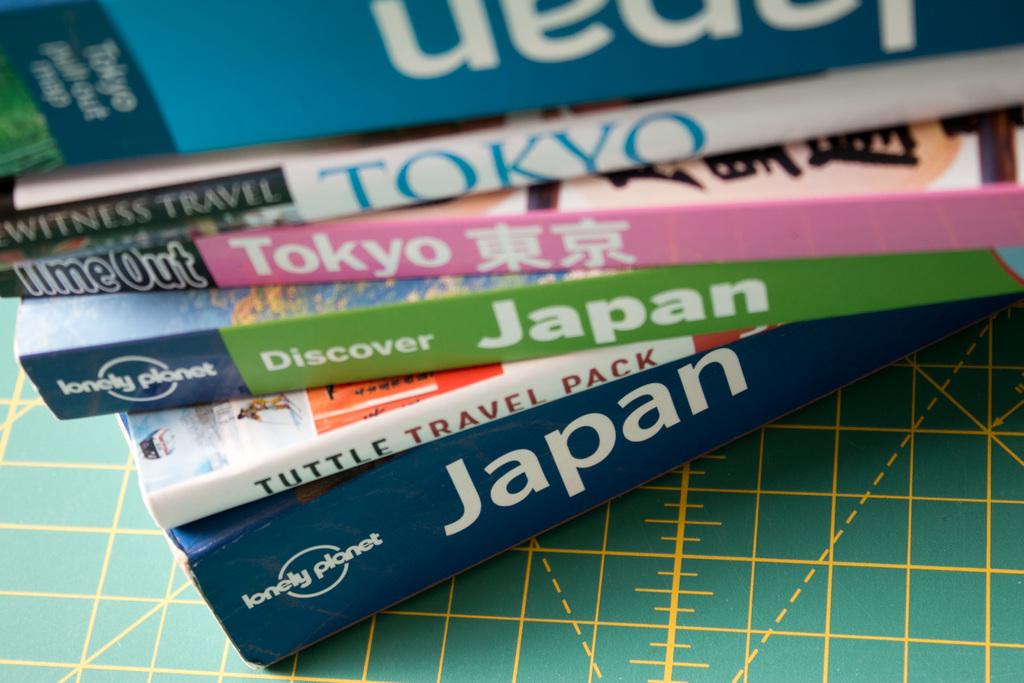What logo is on the bottom most book?
Give a very brief answer. Lonely planet. 